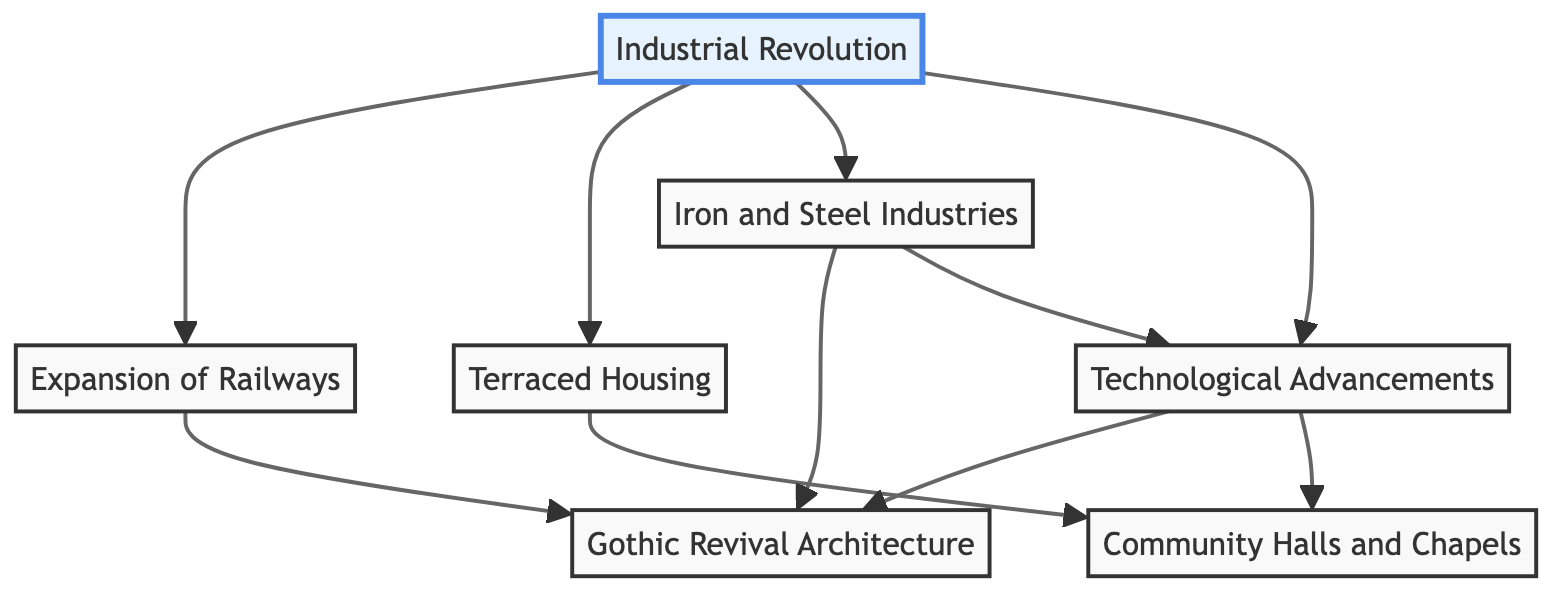What is the first node in the diagram? The first node is "Industrial Revolution," which is connected to all other nodes depicting the influences of industrialization on architecture.
Answer: Industrial Revolution How many nodes are directly connected to the "Industrial Revolution"? The "Industrial Revolution" node has four direct connections: "Expansion of Railways," "Terraced Housing," "Iron and Steel Industries," and "Technological Advancements."
Answer: 4 Which architectural style is influenced by both the "Expansion of Railways" and "Iron and Steel Industries"? The "Gothic Revival Architecture" is connected to both the "Expansion of Railways" and "Iron and Steel Industries," indicating its influence from both areas.
Answer: Gothic Revival Architecture From which node does "Community Halls and Chapels" originate? "Community Halls and Chapels" stem from the "Terraced Housing" node, meaning it is directly affected by the rise in terraced houses due to industrialization.
Answer: Terraced Housing What influences led to "Technological Advancements" in construction? "Technological Advancements" are influenced by "Iron and Steel Industries" and the overall "Industrial Revolution," which suggest innovations in building techniques.
Answer: Iron and Steel Industries, Industrial Revolution List all nodes that are connected to "Gothic Revival Architecture". "Gothic Revival Architecture" is connected to three nodes: "Expansion of Railways," "Iron and Steel Industries," and "Technological Advancements," highlighting its multiple influences.
Answer: Expansion of Railways, Iron and Steel Industries, Technological Advancements What is the relationship between "Iron and Steel Industries" and "Technological Advancements"? "Iron and Steel Industries" leads to "Technological Advancements," showing that developments in these industries contributed to advancements in construction technology.
Answer: Leads to Which element depicts the architectural response to the workforce growth? The "Terraced Housing" element depicts the architectural response to the growing workforce in industrial towns, indicating a need for housing.
Answer: Terraced Housing How many types of architectural styles are depicted in the diagram? The diagram represents one prominent architectural style, "Gothic Revival Architecture," influenced by industrial trends, as indicated by the connections.
Answer: 1 